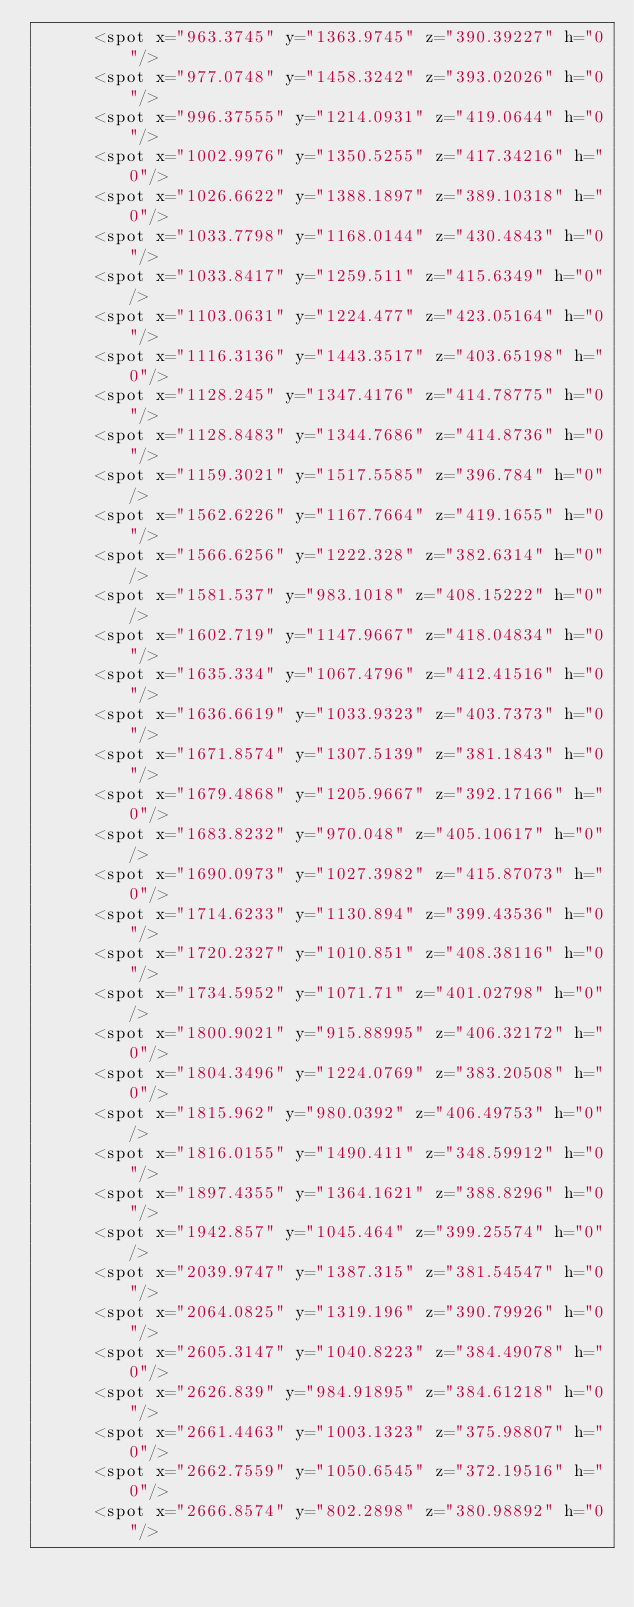<code> <loc_0><loc_0><loc_500><loc_500><_XML_>			<spot x="963.3745" y="1363.9745" z="390.39227" h="0"/>
			<spot x="977.0748" y="1458.3242" z="393.02026" h="0"/>
			<spot x="996.37555" y="1214.0931" z="419.0644" h="0"/>
			<spot x="1002.9976" y="1350.5255" z="417.34216" h="0"/>
			<spot x="1026.6622" y="1388.1897" z="389.10318" h="0"/>
			<spot x="1033.7798" y="1168.0144" z="430.4843" h="0"/>
			<spot x="1033.8417" y="1259.511" z="415.6349" h="0"/>
			<spot x="1103.0631" y="1224.477" z="423.05164" h="0"/>
			<spot x="1116.3136" y="1443.3517" z="403.65198" h="0"/>
			<spot x="1128.245" y="1347.4176" z="414.78775" h="0"/>
			<spot x="1128.8483" y="1344.7686" z="414.8736" h="0"/>
			<spot x="1159.3021" y="1517.5585" z="396.784" h="0"/>
			<spot x="1562.6226" y="1167.7664" z="419.1655" h="0"/>
			<spot x="1566.6256" y="1222.328" z="382.6314" h="0"/>
			<spot x="1581.537" y="983.1018" z="408.15222" h="0"/>
			<spot x="1602.719" y="1147.9667" z="418.04834" h="0"/>
			<spot x="1635.334" y="1067.4796" z="412.41516" h="0"/>
			<spot x="1636.6619" y="1033.9323" z="403.7373" h="0"/>
			<spot x="1671.8574" y="1307.5139" z="381.1843" h="0"/>
			<spot x="1679.4868" y="1205.9667" z="392.17166" h="0"/>
			<spot x="1683.8232" y="970.048" z="405.10617" h="0"/>
			<spot x="1690.0973" y="1027.3982" z="415.87073" h="0"/>
			<spot x="1714.6233" y="1130.894" z="399.43536" h="0"/>
			<spot x="1720.2327" y="1010.851" z="408.38116" h="0"/>
			<spot x="1734.5952" y="1071.71" z="401.02798" h="0"/>
			<spot x="1800.9021" y="915.88995" z="406.32172" h="0"/>
			<spot x="1804.3496" y="1224.0769" z="383.20508" h="0"/>
			<spot x="1815.962" y="980.0392" z="406.49753" h="0"/>
			<spot x="1816.0155" y="1490.411" z="348.59912" h="0"/>
			<spot x="1897.4355" y="1364.1621" z="388.8296" h="0"/>
			<spot x="1942.857" y="1045.464" z="399.25574" h="0"/>
			<spot x="2039.9747" y="1387.315" z="381.54547" h="0"/>
			<spot x="2064.0825" y="1319.196" z="390.79926" h="0"/>
			<spot x="2605.3147" y="1040.8223" z="384.49078" h="0"/>
			<spot x="2626.839" y="984.91895" z="384.61218" h="0"/>
			<spot x="2661.4463" y="1003.1323" z="375.98807" h="0"/>
			<spot x="2662.7559" y="1050.6545" z="372.19516" h="0"/>
			<spot x="2666.8574" y="802.2898" z="380.98892" h="0"/></code> 